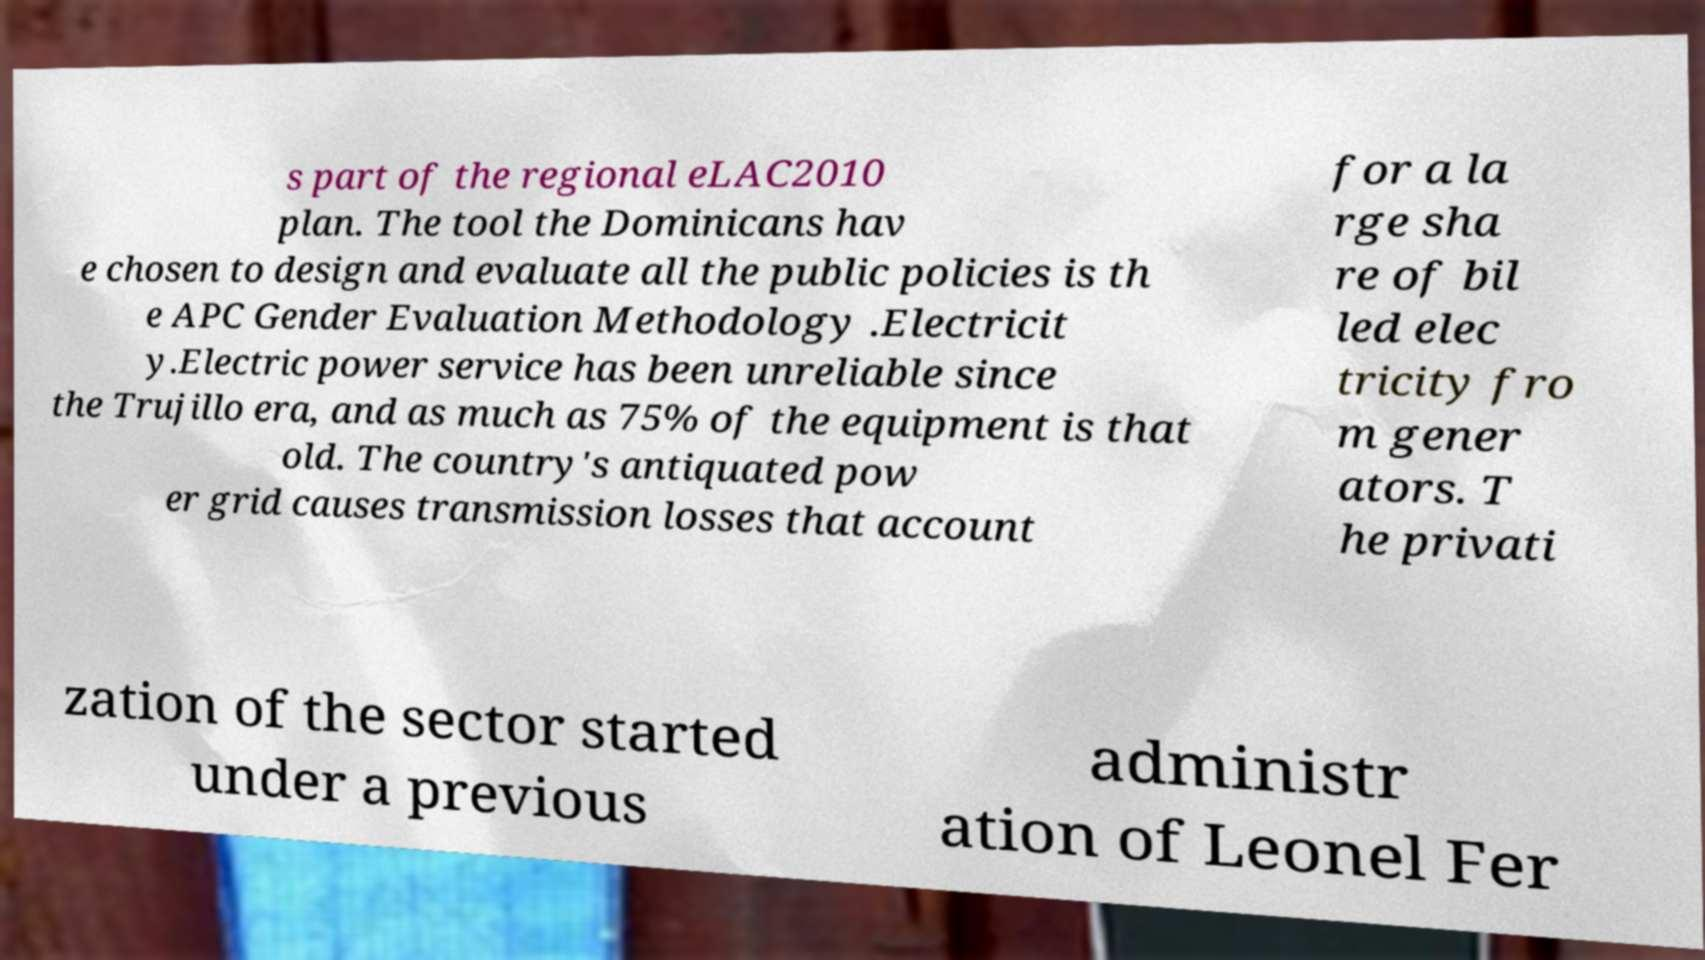Please read and relay the text visible in this image. What does it say? s part of the regional eLAC2010 plan. The tool the Dominicans hav e chosen to design and evaluate all the public policies is th e APC Gender Evaluation Methodology .Electricit y.Electric power service has been unreliable since the Trujillo era, and as much as 75% of the equipment is that old. The country's antiquated pow er grid causes transmission losses that account for a la rge sha re of bil led elec tricity fro m gener ators. T he privati zation of the sector started under a previous administr ation of Leonel Fer 